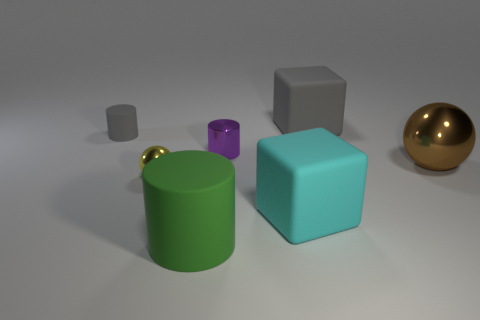Add 1 tiny green metal blocks. How many objects exist? 8 Subtract all cubes. How many objects are left? 5 Add 1 large metal things. How many large metal things are left? 2 Add 3 spheres. How many spheres exist? 5 Subtract 0 red cubes. How many objects are left? 7 Subtract all big brown rubber cylinders. Subtract all gray things. How many objects are left? 5 